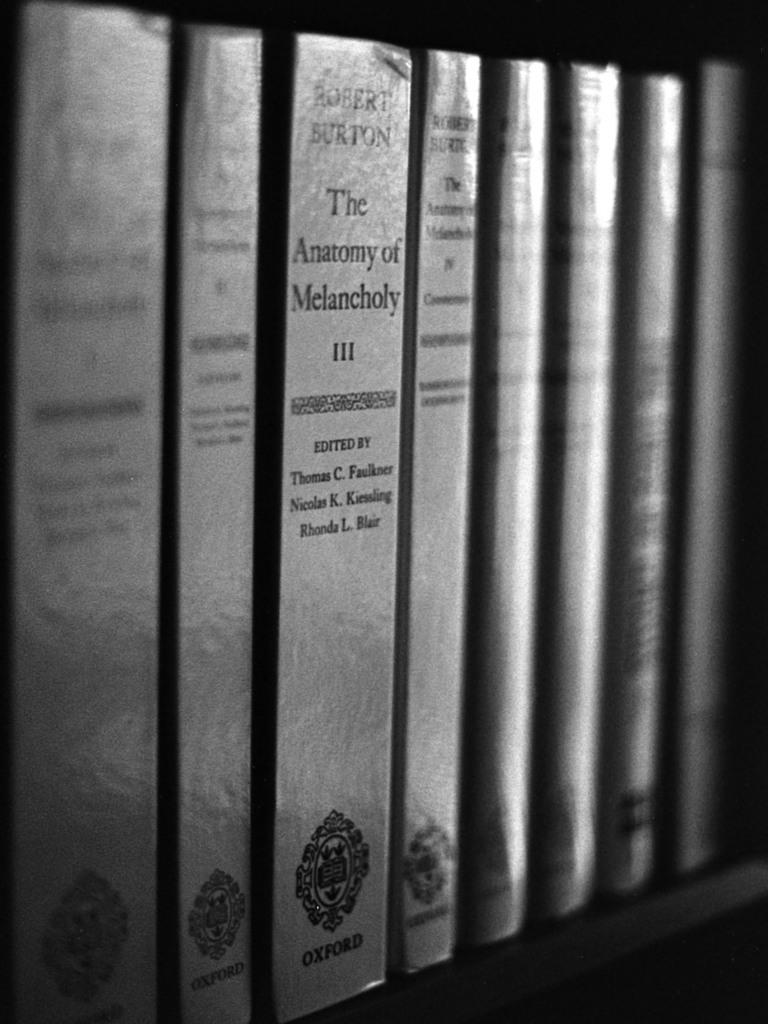Provide a one-sentence caption for the provided image. Books line a shelf in black and white, one of the books is titled "The Anatomy of Melancholy.". 